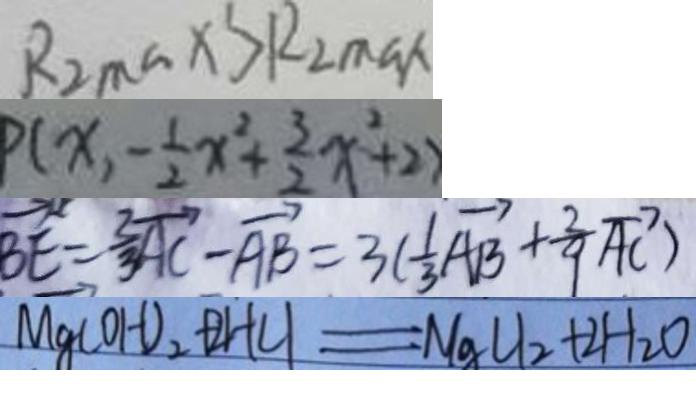Convert formula to latex. <formula><loc_0><loc_0><loc_500><loc_500>R _ { 2 \max } > R _ { 2 \max } 
 P ( x , - \frac { 1 } { 2 } x ^ { 2 } + \frac { 3 } { 2 } x ^ { 2 } + 2 ) 
 \overrightarrow { B E } = \frac { 2 } { 3 } \overrightarrow { A C } - \overrightarrow { A B } = 3 ( \frac { 1 } { 3 } \overrightarrow { A B } + \frac { 2 } { 9 } \overrightarrow { A C } ) 
 M g ( O H ) _ { 2 } + 2 H C l = M g C l _ { 2 } + 2 H _ { 2 } O</formula> 